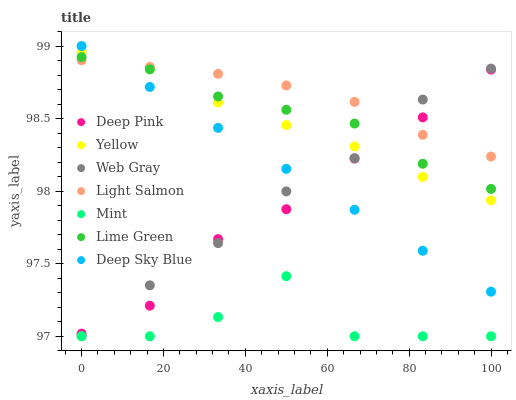Does Mint have the minimum area under the curve?
Answer yes or no. Yes. Does Light Salmon have the maximum area under the curve?
Answer yes or no. Yes. Does Deep Pink have the minimum area under the curve?
Answer yes or no. No. Does Deep Pink have the maximum area under the curve?
Answer yes or no. No. Is Deep Sky Blue the smoothest?
Answer yes or no. Yes. Is Mint the roughest?
Answer yes or no. Yes. Is Deep Pink the smoothest?
Answer yes or no. No. Is Deep Pink the roughest?
Answer yes or no. No. Does Mint have the lowest value?
Answer yes or no. Yes. Does Deep Pink have the lowest value?
Answer yes or no. No. Does Deep Sky Blue have the highest value?
Answer yes or no. Yes. Does Deep Pink have the highest value?
Answer yes or no. No. Is Mint less than Lime Green?
Answer yes or no. Yes. Is Web Gray greater than Mint?
Answer yes or no. Yes. Does Deep Sky Blue intersect Light Salmon?
Answer yes or no. Yes. Is Deep Sky Blue less than Light Salmon?
Answer yes or no. No. Is Deep Sky Blue greater than Light Salmon?
Answer yes or no. No. Does Mint intersect Lime Green?
Answer yes or no. No. 